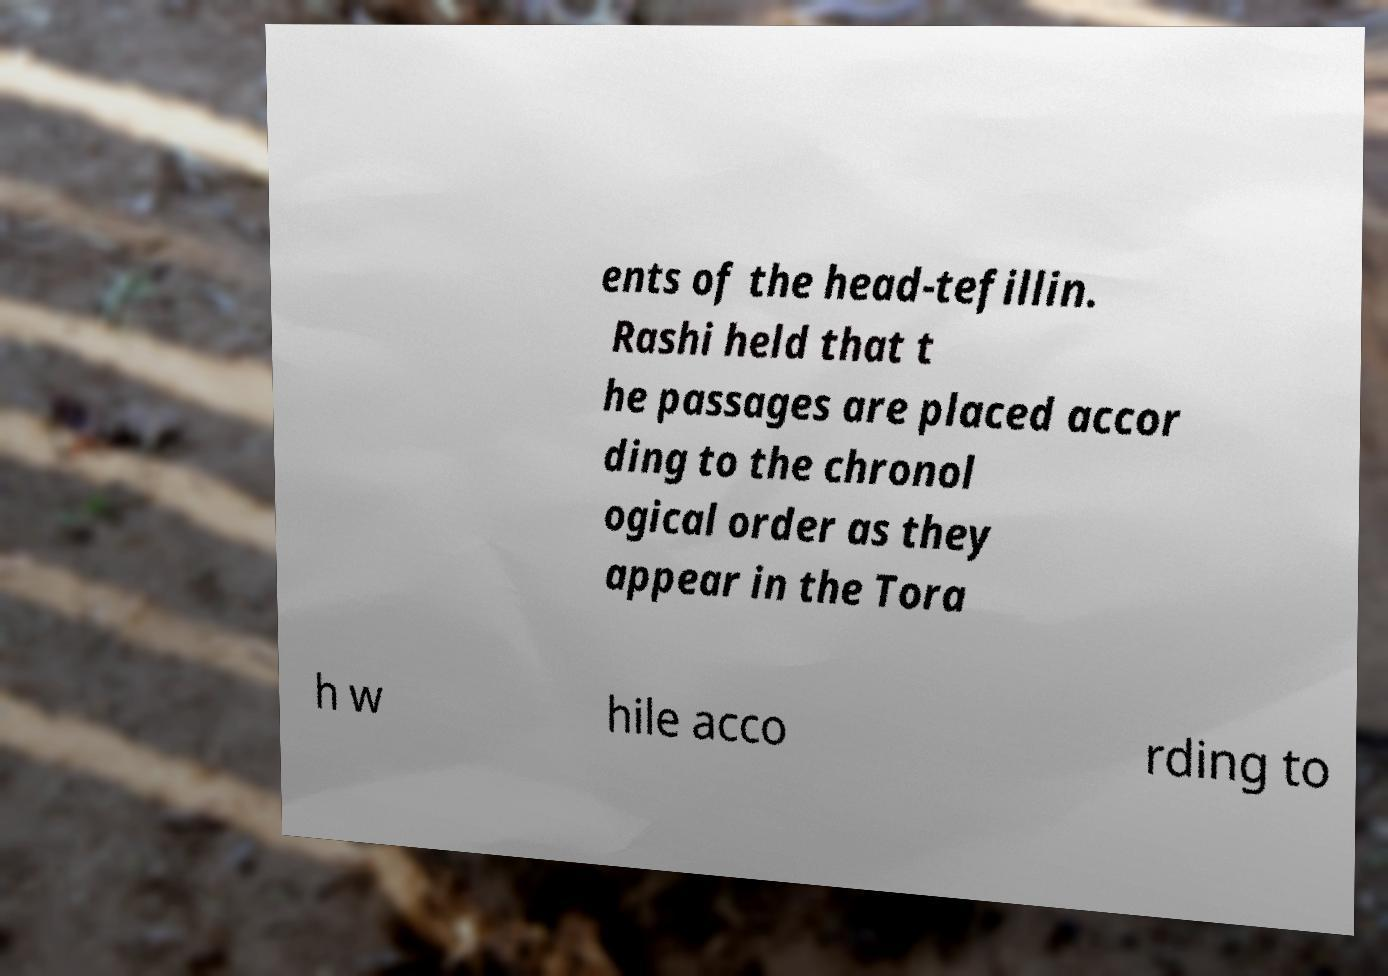Could you extract and type out the text from this image? ents of the head-tefillin. Rashi held that t he passages are placed accor ding to the chronol ogical order as they appear in the Tora h w hile acco rding to 